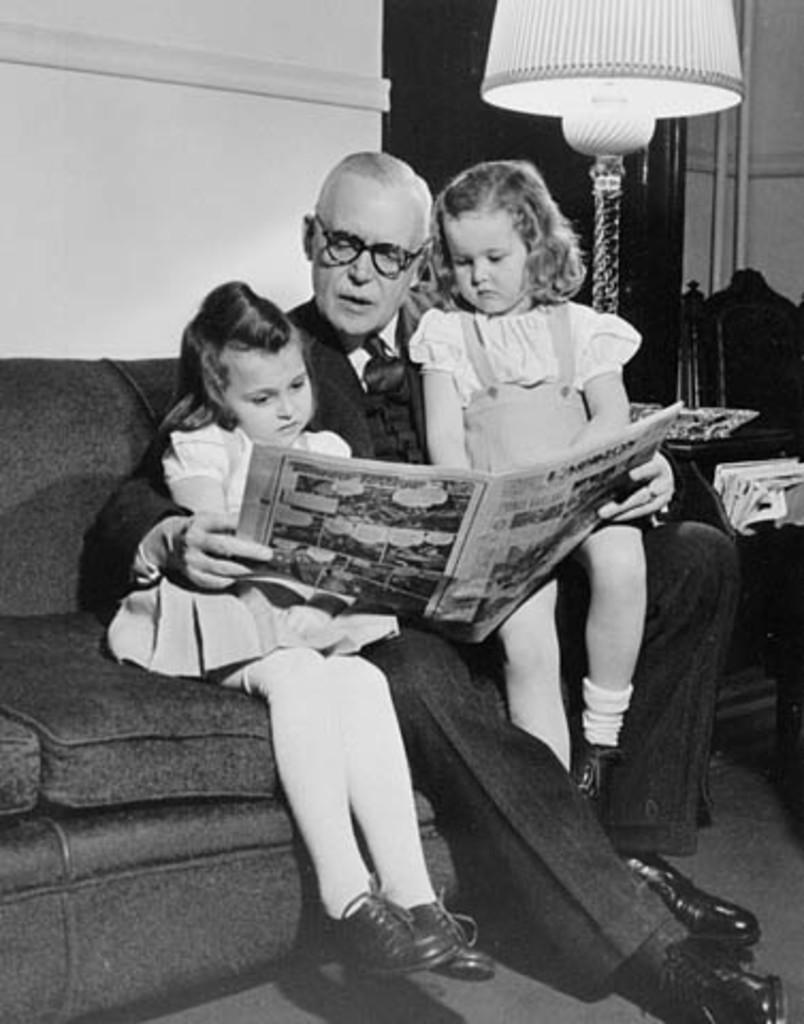Who is the main subject in the image? There is a man in the image. What is the man doing in the image? The man is sitting on a sofa and reading a newspaper. What else is the man holding in the image? The man is holding two babies. What object can be seen in the image that provides light? There is a lamp in the image. What channel is the man watching on the television in the image? There is no television present in the image, so it is not possible to determine what channel the man might be watching. 